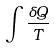Convert formula to latex. <formula><loc_0><loc_0><loc_500><loc_500>\int \frac { \delta Q } { T }</formula> 